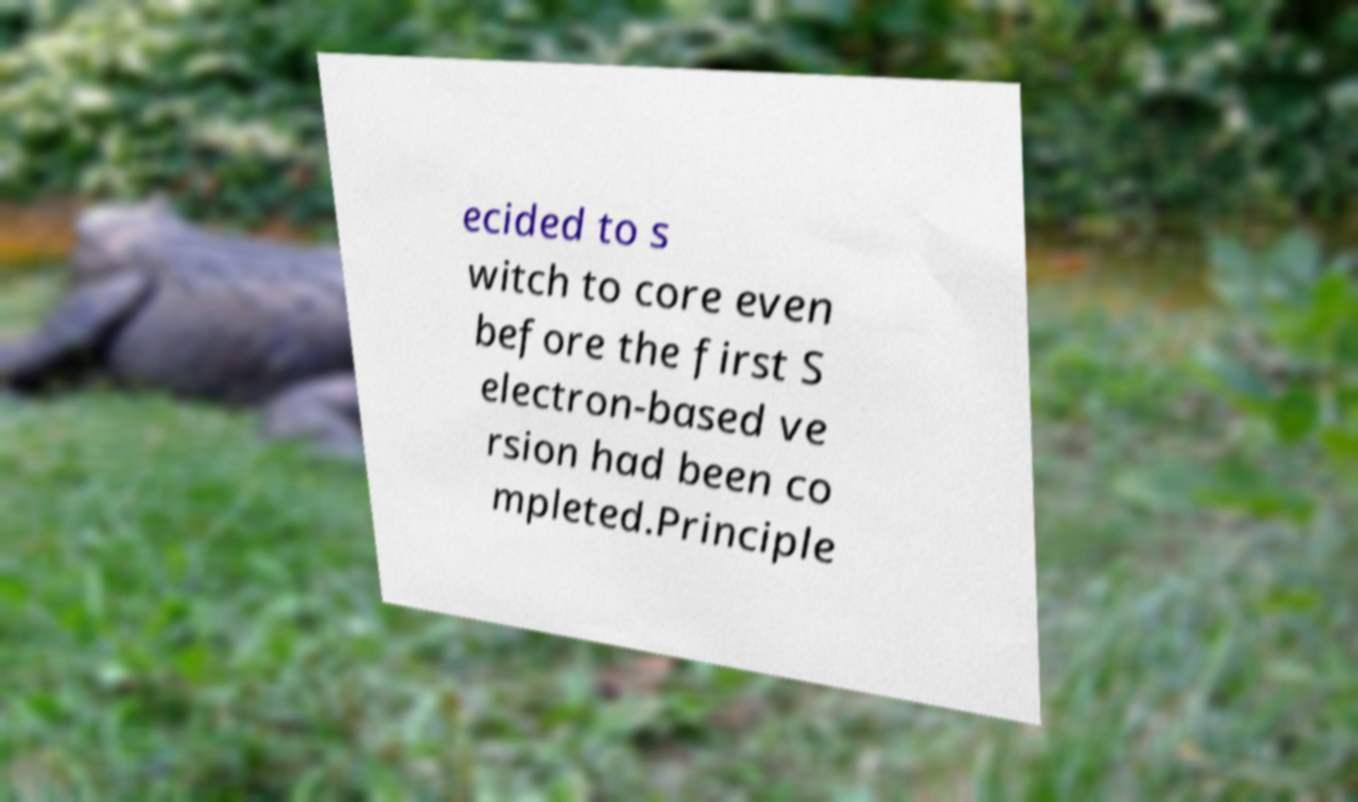Please read and relay the text visible in this image. What does it say? ecided to s witch to core even before the first S electron-based ve rsion had been co mpleted.Principle 